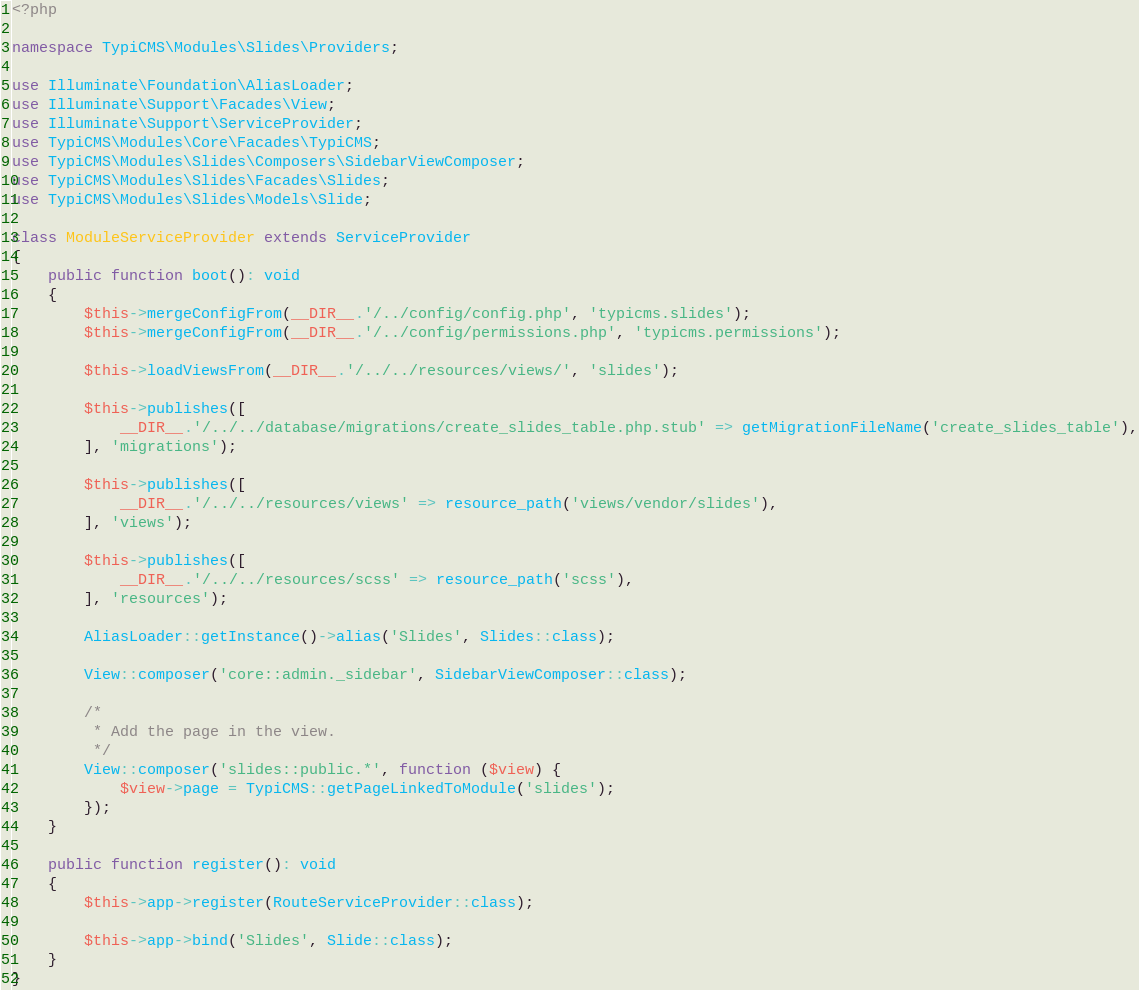<code> <loc_0><loc_0><loc_500><loc_500><_PHP_><?php

namespace TypiCMS\Modules\Slides\Providers;

use Illuminate\Foundation\AliasLoader;
use Illuminate\Support\Facades\View;
use Illuminate\Support\ServiceProvider;
use TypiCMS\Modules\Core\Facades\TypiCMS;
use TypiCMS\Modules\Slides\Composers\SidebarViewComposer;
use TypiCMS\Modules\Slides\Facades\Slides;
use TypiCMS\Modules\Slides\Models\Slide;

class ModuleServiceProvider extends ServiceProvider
{
    public function boot(): void
    {
        $this->mergeConfigFrom(__DIR__.'/../config/config.php', 'typicms.slides');
        $this->mergeConfigFrom(__DIR__.'/../config/permissions.php', 'typicms.permissions');

        $this->loadViewsFrom(__DIR__.'/../../resources/views/', 'slides');

        $this->publishes([
            __DIR__.'/../../database/migrations/create_slides_table.php.stub' => getMigrationFileName('create_slides_table'),
        ], 'migrations');

        $this->publishes([
            __DIR__.'/../../resources/views' => resource_path('views/vendor/slides'),
        ], 'views');

        $this->publishes([
            __DIR__.'/../../resources/scss' => resource_path('scss'),
        ], 'resources');

        AliasLoader::getInstance()->alias('Slides', Slides::class);

        View::composer('core::admin._sidebar', SidebarViewComposer::class);

        /*
         * Add the page in the view.
         */
        View::composer('slides::public.*', function ($view) {
            $view->page = TypiCMS::getPageLinkedToModule('slides');
        });
    }

    public function register(): void
    {
        $this->app->register(RouteServiceProvider::class);

        $this->app->bind('Slides', Slide::class);
    }
}
</code> 